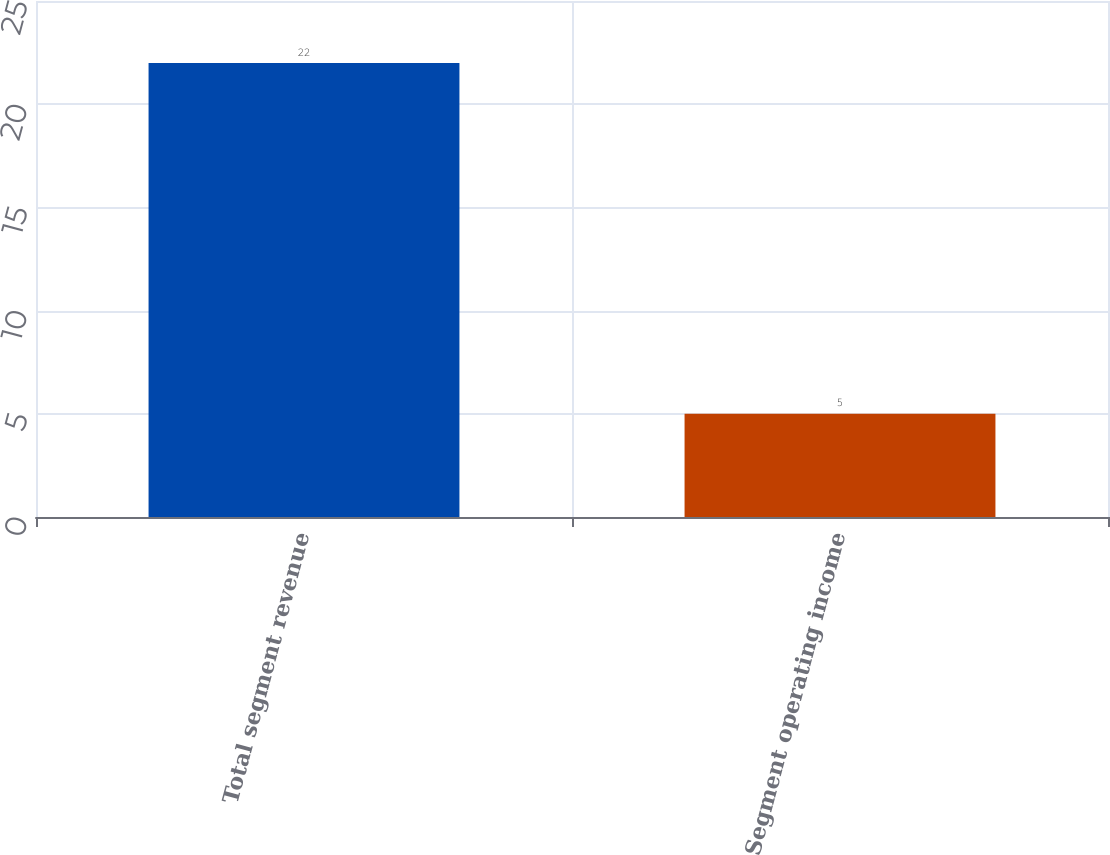Convert chart to OTSL. <chart><loc_0><loc_0><loc_500><loc_500><bar_chart><fcel>Total segment revenue<fcel>Segment operating income<nl><fcel>22<fcel>5<nl></chart> 